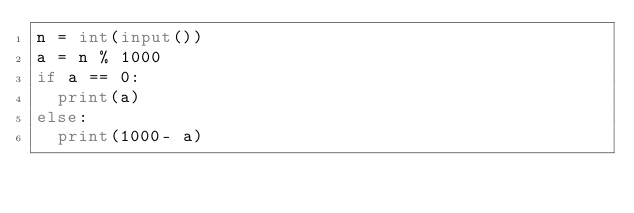<code> <loc_0><loc_0><loc_500><loc_500><_Python_>n = int(input())
a = n % 1000
if a == 0:
  print(a)
else:
  print(1000- a)</code> 